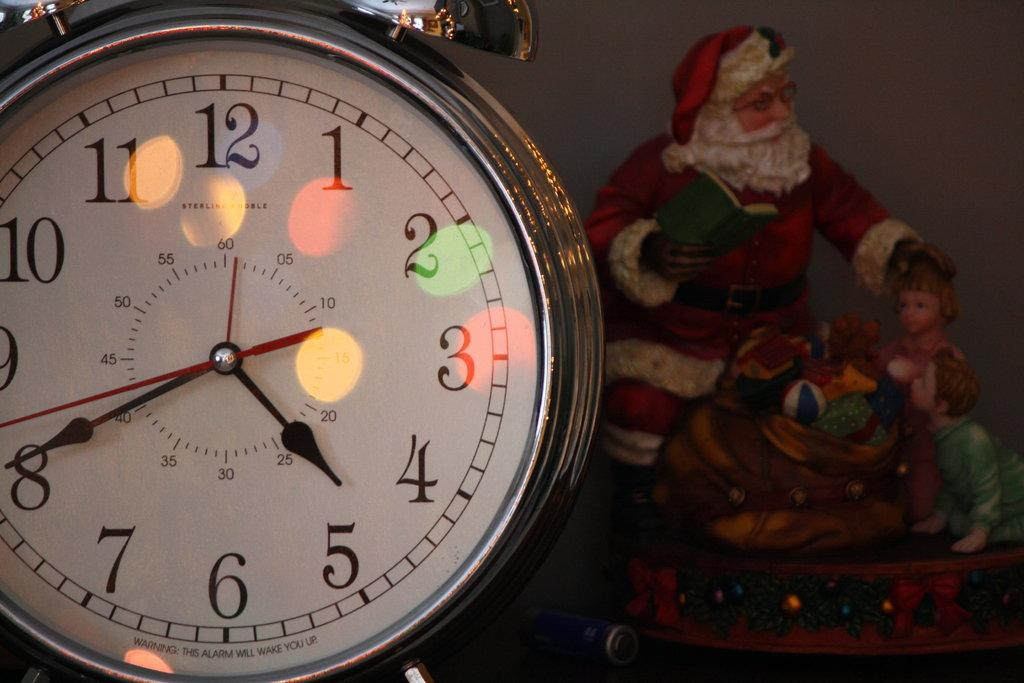<image>
Provide a brief description of the given image. A clock with a tiny warning on the bottom that states that the alarm will wake you up 